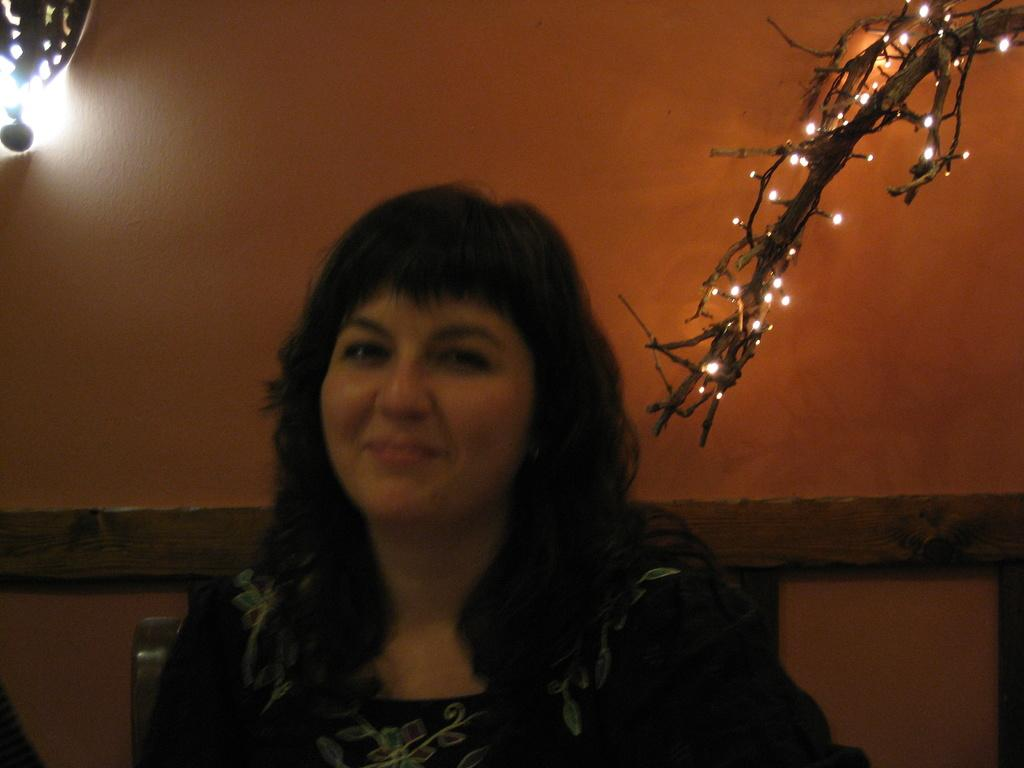Who is present in the image? There is a lady in the image. What can be seen in the background of the image? There is a wall in the background of the image. What is on the right side of the image? There is a branch with lights on the right side of the image. What type of lighting is present on the wall in the image? There is a light on the wall in the image. What type of grain is visible in the image? There is no grain present in the image. 